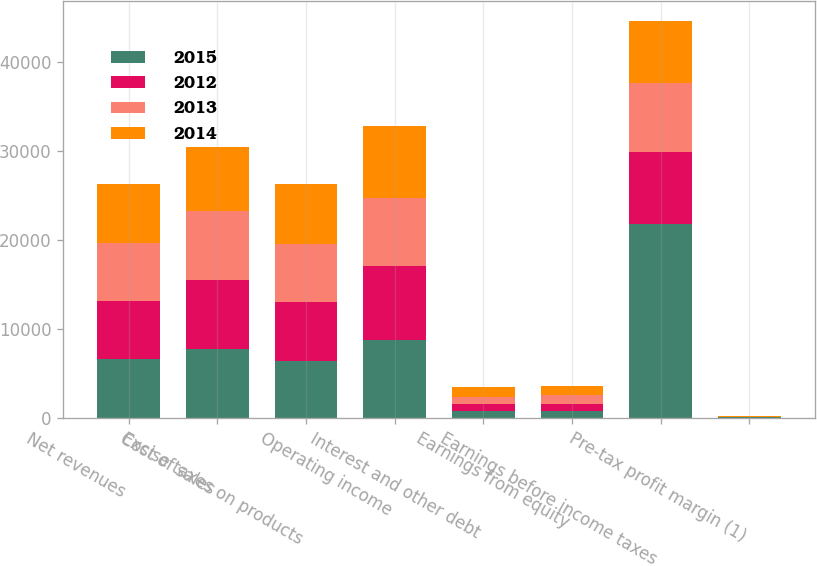Convert chart. <chart><loc_0><loc_0><loc_500><loc_500><stacked_bar_chart><ecel><fcel>Net revenues<fcel>Cost of sales<fcel>Excise taxes on products<fcel>Operating income<fcel>Interest and other debt<fcel>Earnings from equity<fcel>Earnings before income taxes<fcel>Pre-tax profit margin (1)<nl><fcel>2015<fcel>6578.5<fcel>7746<fcel>6407<fcel>8762<fcel>747<fcel>795<fcel>21852<fcel>84.9<nl><fcel>2012<fcel>6578.5<fcel>7740<fcel>6580<fcel>8361<fcel>817<fcel>757<fcel>8078<fcel>31.8<nl><fcel>2013<fcel>6578.5<fcel>7785<fcel>6577<fcel>7620<fcel>808<fcel>1006<fcel>7774<fcel>31.7<nl><fcel>2014<fcel>6578.5<fcel>7206<fcel>6803<fcel>8084<fcel>1049<fcel>991<fcel>6942<fcel>28.4<nl></chart> 